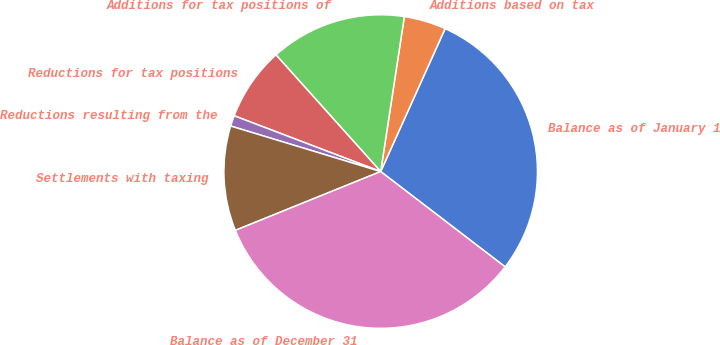Convert chart. <chart><loc_0><loc_0><loc_500><loc_500><pie_chart><fcel>Balance as of January 1<fcel>Additions based on tax<fcel>Additions for tax positions of<fcel>Reductions for tax positions<fcel>Reductions resulting from the<fcel>Settlements with taxing<fcel>Balance as of December 31<nl><fcel>28.66%<fcel>4.33%<fcel>14.05%<fcel>7.57%<fcel>1.1%<fcel>10.81%<fcel>33.48%<nl></chart> 